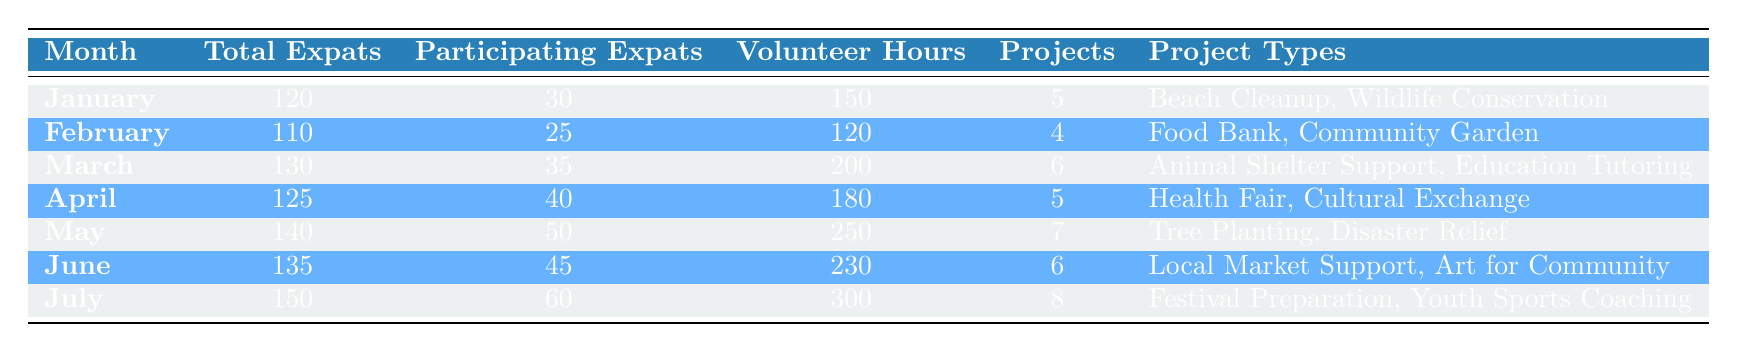What was the total number of volunteer hours in June? According to the table, the volunteer hours listed for June is 230.
Answer: 230 How many projects were involved in community activities in May? The table shows that there were 7 projects involved in May.
Answer: 7 Which month had the highest number of participating expats? By examining the table, July shows the highest number of participating expats, totaling 60.
Answer: July What is the average number of volunteer hours across all months listed? To find the average, we sum the volunteer hours: (150 + 120 + 200 + 180 + 250 + 230 + 300) = 1430. Then, dividing by the number of months (7) gives us 1430 / 7 = 204.3.
Answer: 204.3 Did more than 40 expats participate in community projects in April? In April, the table indicates that 40 expats participated, therefore the answer is false.
Answer: No Which month had the least participation in projects, and what were the project types? February reported the least participation at 25 expats. The project types listed for February are Food Bank and Community Garden.
Answer: February, Food Bank and Community Garden How many more expats participated in July compared to January? In July, 60 expats participated compared to 30 in January. The difference is 60 - 30 = 30, meaning 30 more expats participated in July.
Answer: 30 Identify the project types listed for the month of March. The table details that the project types for March are Animal Shelter Support and Education Tutoring.
Answer: Animal Shelter Support, Education Tutoring 